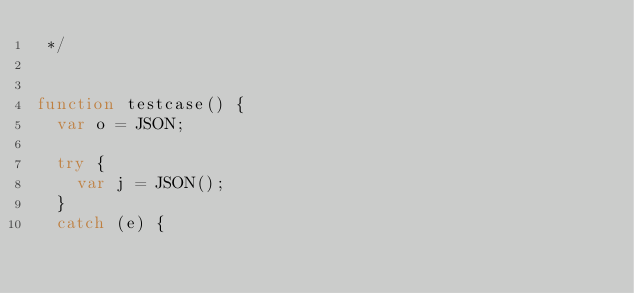<code> <loc_0><loc_0><loc_500><loc_500><_JavaScript_> */


function testcase() {
  var o = JSON;

  try {
    var j = JSON();
  }
  catch (e) {</code> 